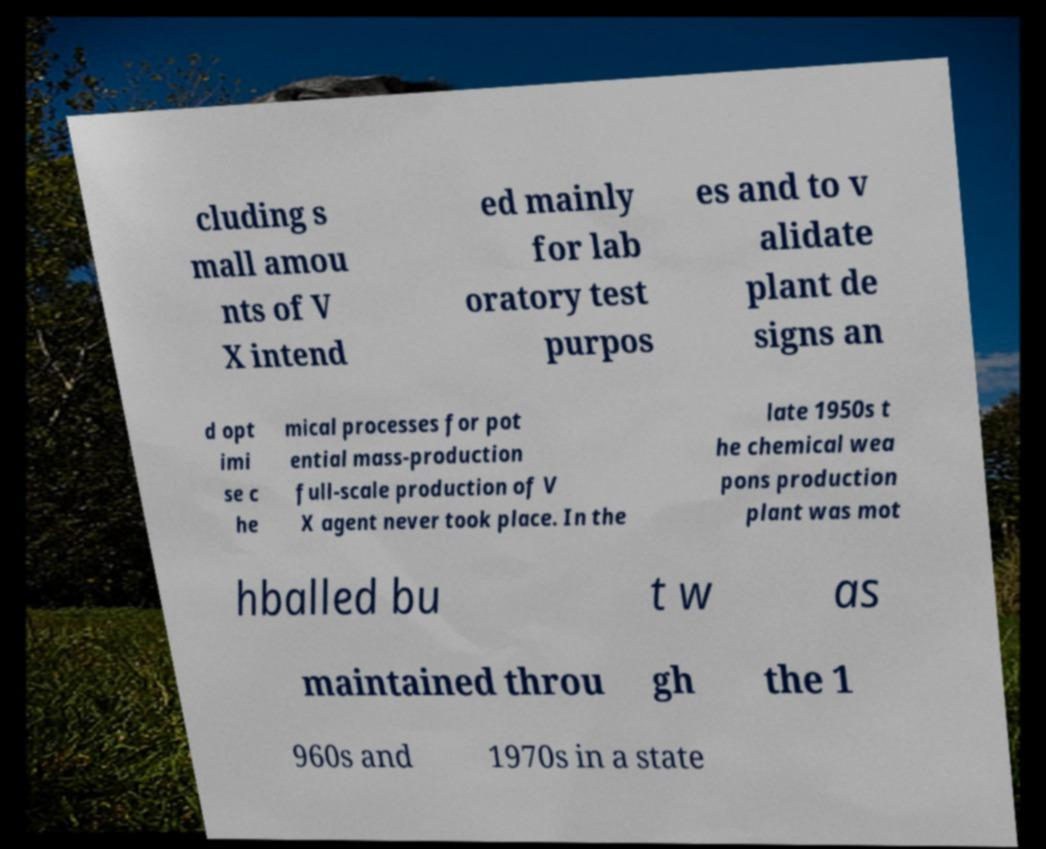For documentation purposes, I need the text within this image transcribed. Could you provide that? cluding s mall amou nts of V X intend ed mainly for lab oratory test purpos es and to v alidate plant de signs an d opt imi se c he mical processes for pot ential mass-production full-scale production of V X agent never took place. In the late 1950s t he chemical wea pons production plant was mot hballed bu t w as maintained throu gh the 1 960s and 1970s in a state 